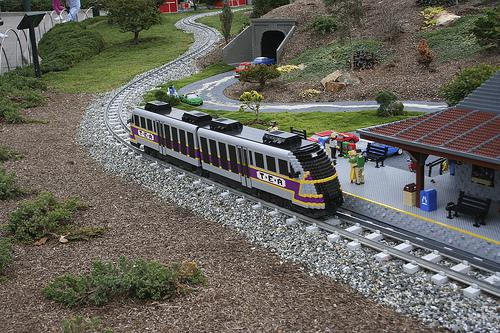Question: where was this taken?
Choices:
A. On the street.
B. Near railroad.
C. Near trains.
D. Train station.
Answer with the letter. Answer: D Question: what color are the tracks?
Choices:
A. Black.
B. Brown.
C. Silver.
D. Red.
Answer with the letter. Answer: C Question: when was this taken?
Choices:
A. Morning.
B. Dusk.
C. Night.
D. Daytime.
Answer with the letter. Answer: D Question: what are the letters on the side of the train?
Choices:
A. Tea.
B. Sugar.
C. Camel.
D. Whiskey.
Answer with the letter. Answer: A Question: how many trains are there?
Choices:
A. 2.
B. 4.
C. 1.
D. 6.
Answer with the letter. Answer: C 